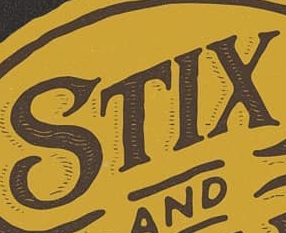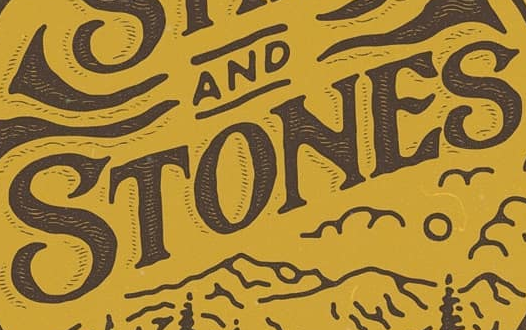Identify the words shown in these images in order, separated by a semicolon. STIX; STONES 